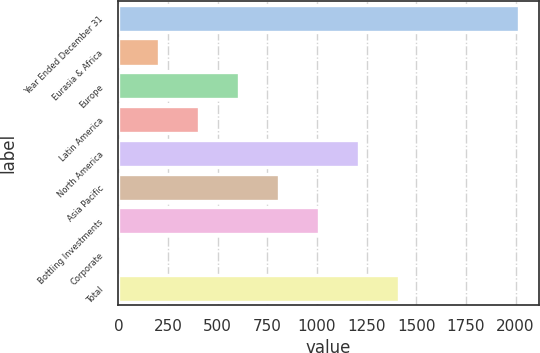<chart> <loc_0><loc_0><loc_500><loc_500><bar_chart><fcel>Year Ended December 31<fcel>Eurasia & Africa<fcel>Europe<fcel>Latin America<fcel>North America<fcel>Asia Pacific<fcel>Bottling Investments<fcel>Corporate<fcel>Total<nl><fcel>2015<fcel>201.77<fcel>604.71<fcel>403.24<fcel>1209.12<fcel>806.18<fcel>1007.65<fcel>0.3<fcel>1410.59<nl></chart> 